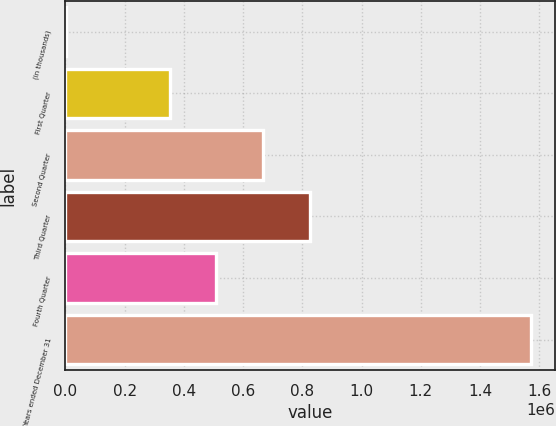Convert chart to OTSL. <chart><loc_0><loc_0><loc_500><loc_500><bar_chart><fcel>(in thousands)<fcel>First Quarter<fcel>Second Quarter<fcel>Third Quarter<fcel>Fourth Quarter<fcel>Years ended December 31<nl><fcel>2016<fcel>352736<fcel>667028<fcel>824174<fcel>509882<fcel>1.57348e+06<nl></chart> 